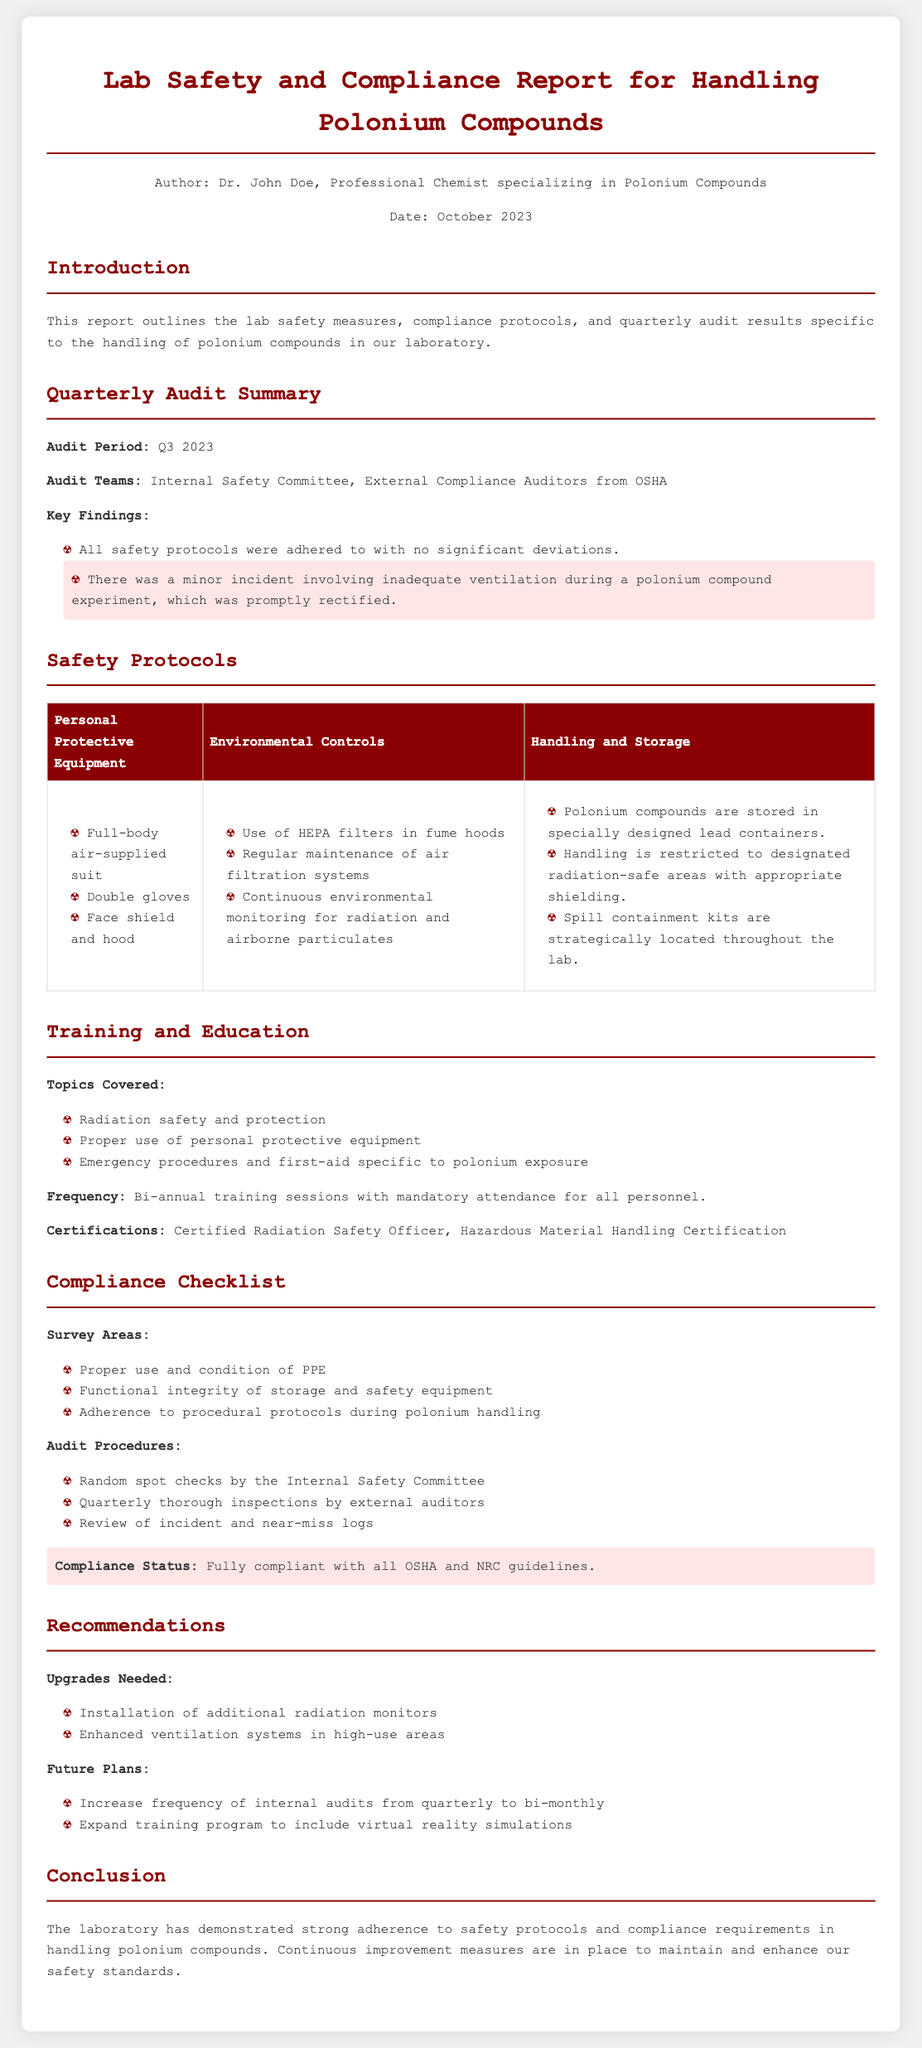What is the audit period? The audit period for the report is explicitly stated in the "Quarterly Audit Summary" section.
Answer: Q3 2023 Who authored the report? The author of the report is mentioned in the header section of the document.
Answer: Dr. John Doe What was a minor incident reported in the audit? The "Key Findings" section notes a minor incident regarding inadequate ventilation.
Answer: Inadequate ventilation What type of training is mandatory for all personnel? The "Training and Education" section specifies the training that is required with mandatory attendance.
Answer: Bi-annual training sessions What is the compliance status? The "Compliance Checklist" section highlights the compliance status regarding OSHA and NRC guidelines.
Answer: Fully compliant with all OSHA and NRC guidelines What equipment is mentioned for personal protection? The safety protocols table lists specific protective equipment for personnel.
Answer: Full-body air-supplied suit What upgrade is needed according to the recommendations? The recommendations section indicates what upgrades are being considered for safety improvements.
Answer: Installation of additional radiation monitors How often are internal audits proposed to increase? The recommendations section suggests a new frequency for internal audits.
Answer: Bi-monthly 